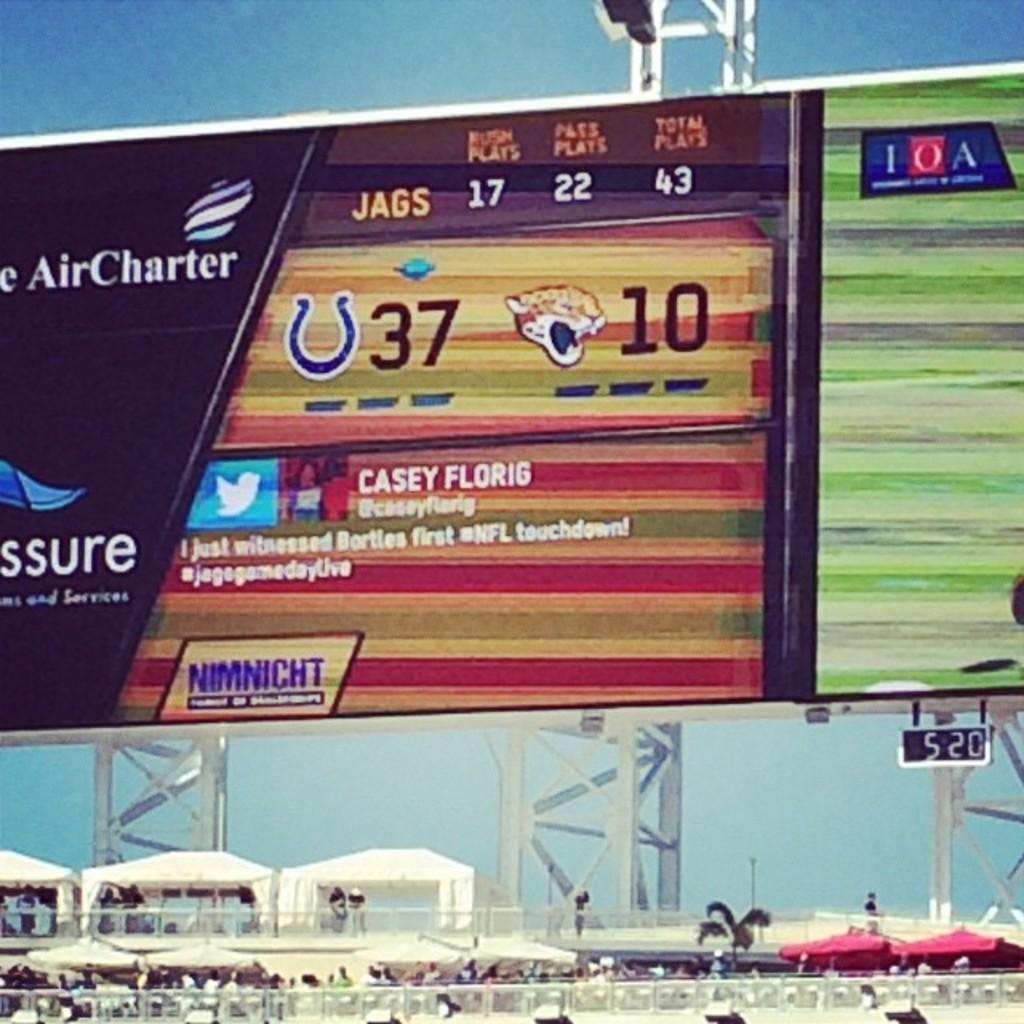<image>
Write a terse but informative summary of the picture. the jags have made 17 rushing plays already 